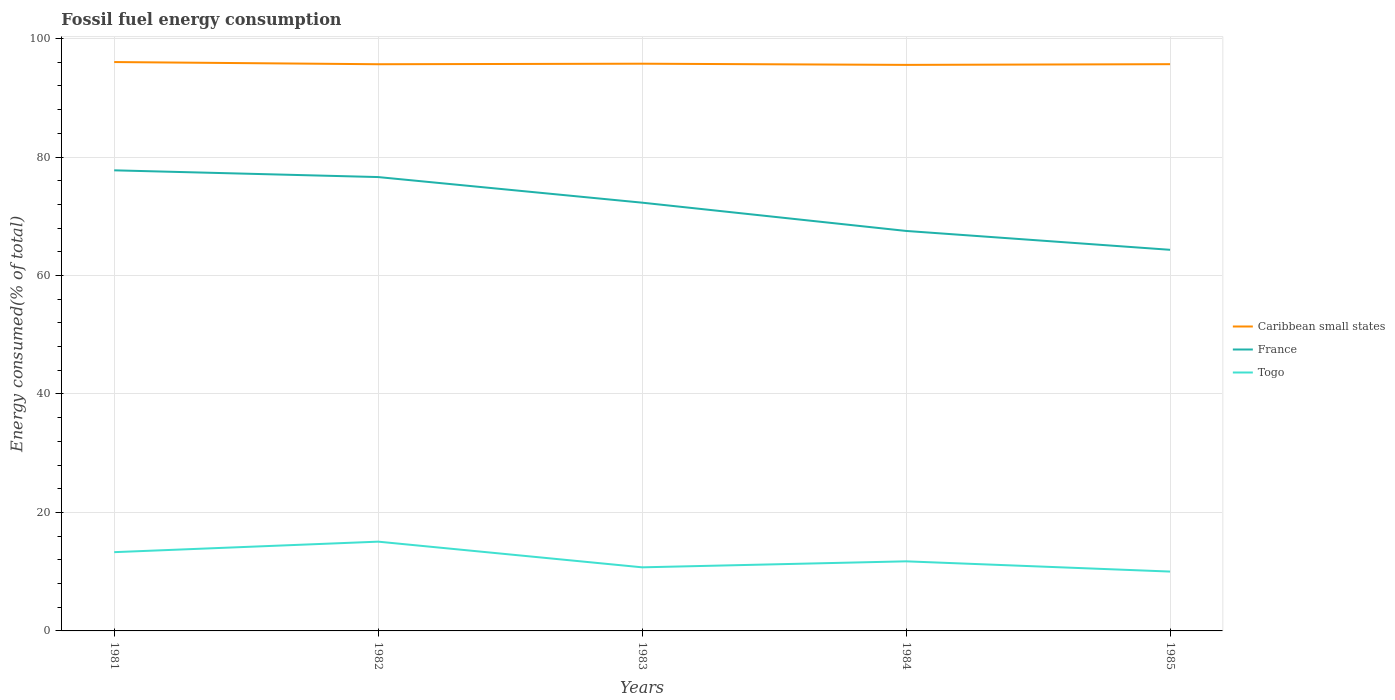Is the number of lines equal to the number of legend labels?
Make the answer very short. Yes. Across all years, what is the maximum percentage of energy consumed in Togo?
Offer a terse response. 10.02. In which year was the percentage of energy consumed in Caribbean small states maximum?
Make the answer very short. 1984. What is the total percentage of energy consumed in France in the graph?
Offer a very short reply. 13.42. What is the difference between the highest and the second highest percentage of energy consumed in Togo?
Offer a very short reply. 5.05. What is the difference between the highest and the lowest percentage of energy consumed in Caribbean small states?
Provide a succinct answer. 2. What is the difference between two consecutive major ticks on the Y-axis?
Provide a short and direct response. 20. Are the values on the major ticks of Y-axis written in scientific E-notation?
Offer a very short reply. No. Does the graph contain any zero values?
Make the answer very short. No. What is the title of the graph?
Ensure brevity in your answer.  Fossil fuel energy consumption. What is the label or title of the Y-axis?
Keep it short and to the point. Energy consumed(% of total). What is the Energy consumed(% of total) of Caribbean small states in 1981?
Make the answer very short. 96.04. What is the Energy consumed(% of total) in France in 1981?
Your response must be concise. 77.76. What is the Energy consumed(% of total) of Togo in 1981?
Keep it short and to the point. 13.3. What is the Energy consumed(% of total) of Caribbean small states in 1982?
Keep it short and to the point. 95.67. What is the Energy consumed(% of total) of France in 1982?
Offer a very short reply. 76.62. What is the Energy consumed(% of total) of Togo in 1982?
Your response must be concise. 15.07. What is the Energy consumed(% of total) in Caribbean small states in 1983?
Ensure brevity in your answer.  95.76. What is the Energy consumed(% of total) of France in 1983?
Provide a short and direct response. 72.3. What is the Energy consumed(% of total) of Togo in 1983?
Your response must be concise. 10.74. What is the Energy consumed(% of total) of Caribbean small states in 1984?
Your answer should be compact. 95.56. What is the Energy consumed(% of total) in France in 1984?
Give a very brief answer. 67.53. What is the Energy consumed(% of total) of Togo in 1984?
Offer a very short reply. 11.75. What is the Energy consumed(% of total) in Caribbean small states in 1985?
Your response must be concise. 95.68. What is the Energy consumed(% of total) of France in 1985?
Your answer should be compact. 64.34. What is the Energy consumed(% of total) of Togo in 1985?
Your response must be concise. 10.02. Across all years, what is the maximum Energy consumed(% of total) of Caribbean small states?
Make the answer very short. 96.04. Across all years, what is the maximum Energy consumed(% of total) of France?
Offer a terse response. 77.76. Across all years, what is the maximum Energy consumed(% of total) in Togo?
Give a very brief answer. 15.07. Across all years, what is the minimum Energy consumed(% of total) of Caribbean small states?
Your answer should be compact. 95.56. Across all years, what is the minimum Energy consumed(% of total) in France?
Ensure brevity in your answer.  64.34. Across all years, what is the minimum Energy consumed(% of total) of Togo?
Offer a very short reply. 10.02. What is the total Energy consumed(% of total) of Caribbean small states in the graph?
Provide a succinct answer. 478.69. What is the total Energy consumed(% of total) in France in the graph?
Provide a succinct answer. 358.54. What is the total Energy consumed(% of total) in Togo in the graph?
Give a very brief answer. 60.87. What is the difference between the Energy consumed(% of total) of Caribbean small states in 1981 and that in 1982?
Offer a terse response. 0.37. What is the difference between the Energy consumed(% of total) in France in 1981 and that in 1982?
Offer a terse response. 1.14. What is the difference between the Energy consumed(% of total) of Togo in 1981 and that in 1982?
Make the answer very short. -1.77. What is the difference between the Energy consumed(% of total) in Caribbean small states in 1981 and that in 1983?
Your answer should be very brief. 0.28. What is the difference between the Energy consumed(% of total) in France in 1981 and that in 1983?
Make the answer very short. 5.46. What is the difference between the Energy consumed(% of total) of Togo in 1981 and that in 1983?
Provide a short and direct response. 2.56. What is the difference between the Energy consumed(% of total) in Caribbean small states in 1981 and that in 1984?
Offer a very short reply. 0.48. What is the difference between the Energy consumed(% of total) in France in 1981 and that in 1984?
Offer a very short reply. 10.23. What is the difference between the Energy consumed(% of total) of Togo in 1981 and that in 1984?
Provide a short and direct response. 1.55. What is the difference between the Energy consumed(% of total) in Caribbean small states in 1981 and that in 1985?
Your answer should be compact. 0.36. What is the difference between the Energy consumed(% of total) of France in 1981 and that in 1985?
Your answer should be compact. 13.42. What is the difference between the Energy consumed(% of total) of Togo in 1981 and that in 1985?
Keep it short and to the point. 3.28. What is the difference between the Energy consumed(% of total) in Caribbean small states in 1982 and that in 1983?
Provide a succinct answer. -0.09. What is the difference between the Energy consumed(% of total) of France in 1982 and that in 1983?
Offer a very short reply. 4.32. What is the difference between the Energy consumed(% of total) of Togo in 1982 and that in 1983?
Ensure brevity in your answer.  4.33. What is the difference between the Energy consumed(% of total) of Caribbean small states in 1982 and that in 1984?
Provide a succinct answer. 0.11. What is the difference between the Energy consumed(% of total) in France in 1982 and that in 1984?
Keep it short and to the point. 9.09. What is the difference between the Energy consumed(% of total) in Togo in 1982 and that in 1984?
Make the answer very short. 3.32. What is the difference between the Energy consumed(% of total) in Caribbean small states in 1982 and that in 1985?
Give a very brief answer. -0.01. What is the difference between the Energy consumed(% of total) of France in 1982 and that in 1985?
Your answer should be compact. 12.28. What is the difference between the Energy consumed(% of total) in Togo in 1982 and that in 1985?
Your answer should be compact. 5.05. What is the difference between the Energy consumed(% of total) in Caribbean small states in 1983 and that in 1984?
Provide a short and direct response. 0.2. What is the difference between the Energy consumed(% of total) of France in 1983 and that in 1984?
Your response must be concise. 4.77. What is the difference between the Energy consumed(% of total) of Togo in 1983 and that in 1984?
Provide a succinct answer. -1.01. What is the difference between the Energy consumed(% of total) in Caribbean small states in 1983 and that in 1985?
Make the answer very short. 0.08. What is the difference between the Energy consumed(% of total) in France in 1983 and that in 1985?
Offer a terse response. 7.96. What is the difference between the Energy consumed(% of total) in Togo in 1983 and that in 1985?
Provide a short and direct response. 0.72. What is the difference between the Energy consumed(% of total) in Caribbean small states in 1984 and that in 1985?
Ensure brevity in your answer.  -0.12. What is the difference between the Energy consumed(% of total) of France in 1984 and that in 1985?
Ensure brevity in your answer.  3.19. What is the difference between the Energy consumed(% of total) of Togo in 1984 and that in 1985?
Give a very brief answer. 1.73. What is the difference between the Energy consumed(% of total) of Caribbean small states in 1981 and the Energy consumed(% of total) of France in 1982?
Keep it short and to the point. 19.42. What is the difference between the Energy consumed(% of total) in Caribbean small states in 1981 and the Energy consumed(% of total) in Togo in 1982?
Offer a very short reply. 80.97. What is the difference between the Energy consumed(% of total) of France in 1981 and the Energy consumed(% of total) of Togo in 1982?
Give a very brief answer. 62.69. What is the difference between the Energy consumed(% of total) in Caribbean small states in 1981 and the Energy consumed(% of total) in France in 1983?
Provide a short and direct response. 23.74. What is the difference between the Energy consumed(% of total) of Caribbean small states in 1981 and the Energy consumed(% of total) of Togo in 1983?
Provide a short and direct response. 85.3. What is the difference between the Energy consumed(% of total) in France in 1981 and the Energy consumed(% of total) in Togo in 1983?
Your answer should be very brief. 67.02. What is the difference between the Energy consumed(% of total) in Caribbean small states in 1981 and the Energy consumed(% of total) in France in 1984?
Your answer should be very brief. 28.51. What is the difference between the Energy consumed(% of total) in Caribbean small states in 1981 and the Energy consumed(% of total) in Togo in 1984?
Offer a terse response. 84.29. What is the difference between the Energy consumed(% of total) in France in 1981 and the Energy consumed(% of total) in Togo in 1984?
Offer a very short reply. 66.01. What is the difference between the Energy consumed(% of total) in Caribbean small states in 1981 and the Energy consumed(% of total) in France in 1985?
Keep it short and to the point. 31.7. What is the difference between the Energy consumed(% of total) of Caribbean small states in 1981 and the Energy consumed(% of total) of Togo in 1985?
Provide a short and direct response. 86.02. What is the difference between the Energy consumed(% of total) of France in 1981 and the Energy consumed(% of total) of Togo in 1985?
Ensure brevity in your answer.  67.74. What is the difference between the Energy consumed(% of total) of Caribbean small states in 1982 and the Energy consumed(% of total) of France in 1983?
Provide a succinct answer. 23.37. What is the difference between the Energy consumed(% of total) in Caribbean small states in 1982 and the Energy consumed(% of total) in Togo in 1983?
Your answer should be compact. 84.93. What is the difference between the Energy consumed(% of total) of France in 1982 and the Energy consumed(% of total) of Togo in 1983?
Offer a very short reply. 65.88. What is the difference between the Energy consumed(% of total) of Caribbean small states in 1982 and the Energy consumed(% of total) of France in 1984?
Ensure brevity in your answer.  28.14. What is the difference between the Energy consumed(% of total) in Caribbean small states in 1982 and the Energy consumed(% of total) in Togo in 1984?
Give a very brief answer. 83.92. What is the difference between the Energy consumed(% of total) of France in 1982 and the Energy consumed(% of total) of Togo in 1984?
Provide a succinct answer. 64.87. What is the difference between the Energy consumed(% of total) in Caribbean small states in 1982 and the Energy consumed(% of total) in France in 1985?
Your answer should be very brief. 31.33. What is the difference between the Energy consumed(% of total) of Caribbean small states in 1982 and the Energy consumed(% of total) of Togo in 1985?
Provide a short and direct response. 85.65. What is the difference between the Energy consumed(% of total) of France in 1982 and the Energy consumed(% of total) of Togo in 1985?
Your answer should be very brief. 66.6. What is the difference between the Energy consumed(% of total) of Caribbean small states in 1983 and the Energy consumed(% of total) of France in 1984?
Provide a short and direct response. 28.23. What is the difference between the Energy consumed(% of total) in Caribbean small states in 1983 and the Energy consumed(% of total) in Togo in 1984?
Offer a terse response. 84.01. What is the difference between the Energy consumed(% of total) of France in 1983 and the Energy consumed(% of total) of Togo in 1984?
Ensure brevity in your answer.  60.55. What is the difference between the Energy consumed(% of total) of Caribbean small states in 1983 and the Energy consumed(% of total) of France in 1985?
Provide a short and direct response. 31.42. What is the difference between the Energy consumed(% of total) in Caribbean small states in 1983 and the Energy consumed(% of total) in Togo in 1985?
Your answer should be compact. 85.74. What is the difference between the Energy consumed(% of total) in France in 1983 and the Energy consumed(% of total) in Togo in 1985?
Your response must be concise. 62.28. What is the difference between the Energy consumed(% of total) in Caribbean small states in 1984 and the Energy consumed(% of total) in France in 1985?
Make the answer very short. 31.22. What is the difference between the Energy consumed(% of total) of Caribbean small states in 1984 and the Energy consumed(% of total) of Togo in 1985?
Offer a very short reply. 85.54. What is the difference between the Energy consumed(% of total) of France in 1984 and the Energy consumed(% of total) of Togo in 1985?
Offer a very short reply. 57.5. What is the average Energy consumed(% of total) in Caribbean small states per year?
Offer a very short reply. 95.74. What is the average Energy consumed(% of total) of France per year?
Provide a short and direct response. 71.71. What is the average Energy consumed(% of total) in Togo per year?
Provide a short and direct response. 12.17. In the year 1981, what is the difference between the Energy consumed(% of total) in Caribbean small states and Energy consumed(% of total) in France?
Ensure brevity in your answer.  18.28. In the year 1981, what is the difference between the Energy consumed(% of total) in Caribbean small states and Energy consumed(% of total) in Togo?
Offer a very short reply. 82.74. In the year 1981, what is the difference between the Energy consumed(% of total) in France and Energy consumed(% of total) in Togo?
Ensure brevity in your answer.  64.46. In the year 1982, what is the difference between the Energy consumed(% of total) in Caribbean small states and Energy consumed(% of total) in France?
Give a very brief answer. 19.05. In the year 1982, what is the difference between the Energy consumed(% of total) in Caribbean small states and Energy consumed(% of total) in Togo?
Provide a short and direct response. 80.6. In the year 1982, what is the difference between the Energy consumed(% of total) of France and Energy consumed(% of total) of Togo?
Provide a succinct answer. 61.55. In the year 1983, what is the difference between the Energy consumed(% of total) in Caribbean small states and Energy consumed(% of total) in France?
Your answer should be very brief. 23.46. In the year 1983, what is the difference between the Energy consumed(% of total) in Caribbean small states and Energy consumed(% of total) in Togo?
Your response must be concise. 85.02. In the year 1983, what is the difference between the Energy consumed(% of total) of France and Energy consumed(% of total) of Togo?
Ensure brevity in your answer.  61.56. In the year 1984, what is the difference between the Energy consumed(% of total) in Caribbean small states and Energy consumed(% of total) in France?
Provide a succinct answer. 28.03. In the year 1984, what is the difference between the Energy consumed(% of total) of Caribbean small states and Energy consumed(% of total) of Togo?
Keep it short and to the point. 83.81. In the year 1984, what is the difference between the Energy consumed(% of total) of France and Energy consumed(% of total) of Togo?
Provide a short and direct response. 55.78. In the year 1985, what is the difference between the Energy consumed(% of total) of Caribbean small states and Energy consumed(% of total) of France?
Provide a succinct answer. 31.34. In the year 1985, what is the difference between the Energy consumed(% of total) of Caribbean small states and Energy consumed(% of total) of Togo?
Your response must be concise. 85.66. In the year 1985, what is the difference between the Energy consumed(% of total) in France and Energy consumed(% of total) in Togo?
Offer a terse response. 54.32. What is the ratio of the Energy consumed(% of total) of Caribbean small states in 1981 to that in 1982?
Make the answer very short. 1. What is the ratio of the Energy consumed(% of total) of France in 1981 to that in 1982?
Ensure brevity in your answer.  1.01. What is the ratio of the Energy consumed(% of total) in Togo in 1981 to that in 1982?
Provide a succinct answer. 0.88. What is the ratio of the Energy consumed(% of total) of Caribbean small states in 1981 to that in 1983?
Ensure brevity in your answer.  1. What is the ratio of the Energy consumed(% of total) of France in 1981 to that in 1983?
Your response must be concise. 1.08. What is the ratio of the Energy consumed(% of total) of Togo in 1981 to that in 1983?
Ensure brevity in your answer.  1.24. What is the ratio of the Energy consumed(% of total) of France in 1981 to that in 1984?
Provide a succinct answer. 1.15. What is the ratio of the Energy consumed(% of total) of Togo in 1981 to that in 1984?
Make the answer very short. 1.13. What is the ratio of the Energy consumed(% of total) of France in 1981 to that in 1985?
Ensure brevity in your answer.  1.21. What is the ratio of the Energy consumed(% of total) in Togo in 1981 to that in 1985?
Provide a short and direct response. 1.33. What is the ratio of the Energy consumed(% of total) in Caribbean small states in 1982 to that in 1983?
Provide a succinct answer. 1. What is the ratio of the Energy consumed(% of total) of France in 1982 to that in 1983?
Ensure brevity in your answer.  1.06. What is the ratio of the Energy consumed(% of total) in Togo in 1982 to that in 1983?
Your response must be concise. 1.4. What is the ratio of the Energy consumed(% of total) in Caribbean small states in 1982 to that in 1984?
Offer a very short reply. 1. What is the ratio of the Energy consumed(% of total) in France in 1982 to that in 1984?
Ensure brevity in your answer.  1.13. What is the ratio of the Energy consumed(% of total) in Togo in 1982 to that in 1984?
Your response must be concise. 1.28. What is the ratio of the Energy consumed(% of total) in Caribbean small states in 1982 to that in 1985?
Keep it short and to the point. 1. What is the ratio of the Energy consumed(% of total) in France in 1982 to that in 1985?
Keep it short and to the point. 1.19. What is the ratio of the Energy consumed(% of total) of Togo in 1982 to that in 1985?
Keep it short and to the point. 1.5. What is the ratio of the Energy consumed(% of total) of France in 1983 to that in 1984?
Your answer should be very brief. 1.07. What is the ratio of the Energy consumed(% of total) of Togo in 1983 to that in 1984?
Offer a very short reply. 0.91. What is the ratio of the Energy consumed(% of total) in France in 1983 to that in 1985?
Ensure brevity in your answer.  1.12. What is the ratio of the Energy consumed(% of total) in Togo in 1983 to that in 1985?
Ensure brevity in your answer.  1.07. What is the ratio of the Energy consumed(% of total) of France in 1984 to that in 1985?
Ensure brevity in your answer.  1.05. What is the ratio of the Energy consumed(% of total) in Togo in 1984 to that in 1985?
Keep it short and to the point. 1.17. What is the difference between the highest and the second highest Energy consumed(% of total) in Caribbean small states?
Make the answer very short. 0.28. What is the difference between the highest and the second highest Energy consumed(% of total) of France?
Keep it short and to the point. 1.14. What is the difference between the highest and the second highest Energy consumed(% of total) in Togo?
Offer a terse response. 1.77. What is the difference between the highest and the lowest Energy consumed(% of total) in Caribbean small states?
Ensure brevity in your answer.  0.48. What is the difference between the highest and the lowest Energy consumed(% of total) of France?
Give a very brief answer. 13.42. What is the difference between the highest and the lowest Energy consumed(% of total) of Togo?
Offer a very short reply. 5.05. 